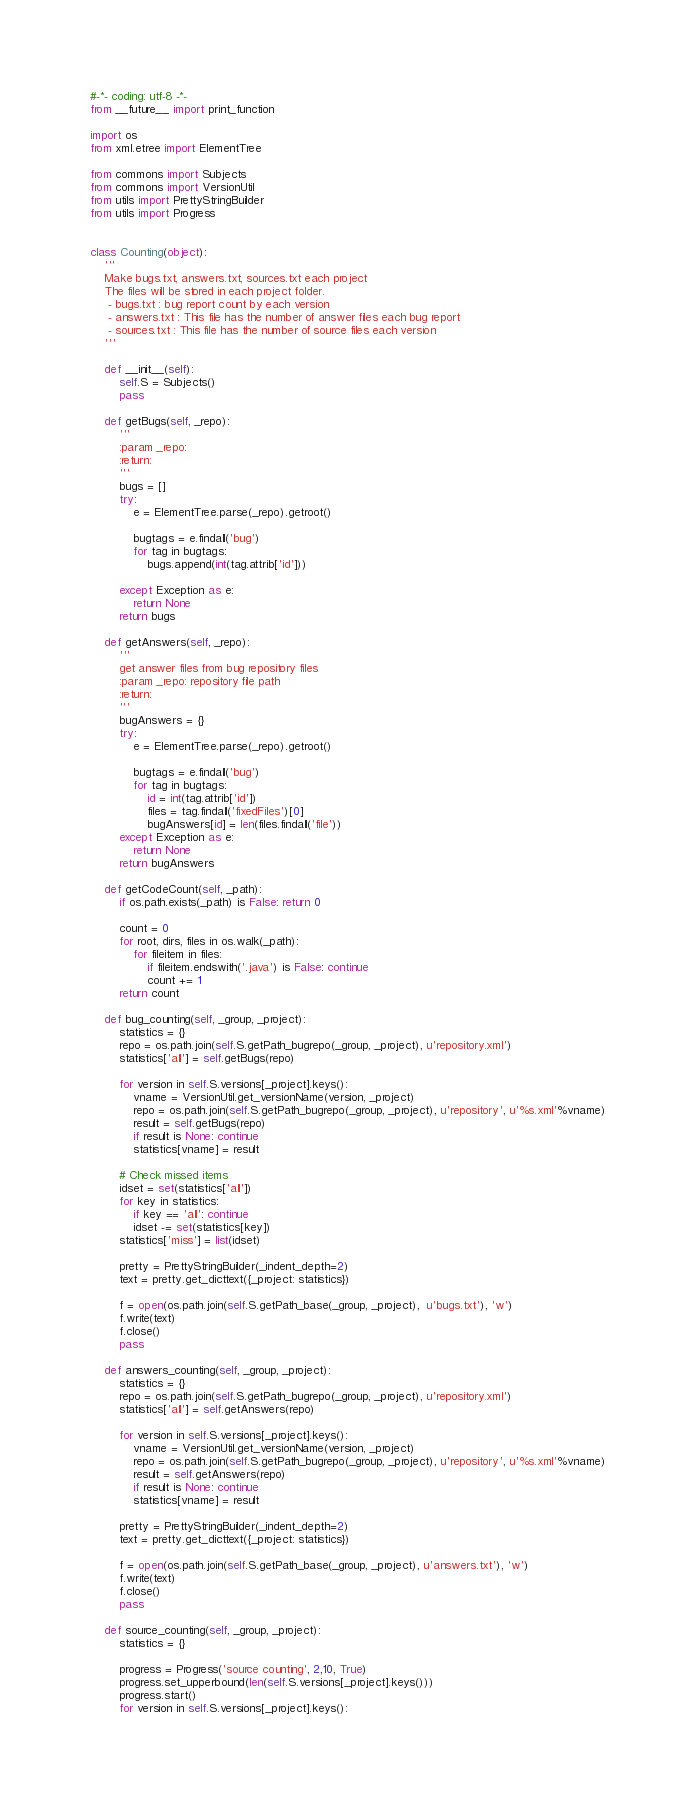Convert code to text. <code><loc_0><loc_0><loc_500><loc_500><_Python_>#-*- coding: utf-8 -*-
from __future__ import print_function

import os
from xml.etree import ElementTree

from commons import Subjects
from commons import VersionUtil
from utils import PrettyStringBuilder
from utils import Progress


class Counting(object):
	'''
	Make bugs.txt, answers.txt, sources.txt each project
	The files will be stored in each project folder.
	 - bugs.txt : bug report count by each version
	 - answers.txt : This file has the number of answer files each bug report
	 - sources.txt : This file has the number of source files each version
	'''

	def __init__(self):
		self.S = Subjects()
		pass

	def getBugs(self, _repo):
		'''
		:param _repo:
		:return:
		'''
		bugs = []
		try:
			e = ElementTree.parse(_repo).getroot()

			bugtags = e.findall('bug')
			for tag in bugtags:
				bugs.append(int(tag.attrib['id']))

		except Exception as e:
			return None
		return bugs

	def getAnswers(self, _repo):
		'''
		get answer files from bug repository files
		:param _repo: repository file path
		:return:
		'''
		bugAnswers = {}
		try:
			e = ElementTree.parse(_repo).getroot()

			bugtags = e.findall('bug')
			for tag in bugtags:
				id = int(tag.attrib['id'])
				files = tag.findall('fixedFiles')[0]
				bugAnswers[id] = len(files.findall('file'))
		except Exception as e:
			return None
		return bugAnswers

	def getCodeCount(self, _path):
		if os.path.exists(_path) is False: return 0

		count = 0
		for root, dirs, files in os.walk(_path):
			for fileitem in files:
				if fileitem.endswith('.java') is False: continue
				count += 1
		return count

	def bug_counting(self, _group, _project):
		statistics = {}
		repo = os.path.join(self.S.getPath_bugrepo(_group, _project), u'repository.xml')
		statistics['all'] = self.getBugs(repo)

		for version in self.S.versions[_project].keys():
			vname = VersionUtil.get_versionName(version, _project)
			repo = os.path.join(self.S.getPath_bugrepo(_group, _project), u'repository', u'%s.xml'%vname)
			result = self.getBugs(repo)
			if result is None: continue
			statistics[vname] = result

		# Check missed items
		idset = set(statistics['all'])
		for key in statistics:
			if key == 'all': continue
			idset -= set(statistics[key])
		statistics['miss'] = list(idset)

		pretty = PrettyStringBuilder(_indent_depth=2)
		text = pretty.get_dicttext({_project: statistics})

		f = open(os.path.join(self.S.getPath_base(_group, _project),  u'bugs.txt'), 'w')
		f.write(text)
		f.close()
		pass

	def answers_counting(self, _group, _project):
		statistics = {}
		repo = os.path.join(self.S.getPath_bugrepo(_group, _project), u'repository.xml')
		statistics['all'] = self.getAnswers(repo)

		for version in self.S.versions[_project].keys():
			vname = VersionUtil.get_versionName(version, _project)
			repo = os.path.join(self.S.getPath_bugrepo(_group, _project), u'repository', u'%s.xml'%vname)
			result = self.getAnswers(repo)
			if result is None: continue
			statistics[vname] = result

		pretty = PrettyStringBuilder(_indent_depth=2)
		text = pretty.get_dicttext({_project: statistics})

		f = open(os.path.join(self.S.getPath_base(_group, _project), u'answers.txt'), 'w')
		f.write(text)
		f.close()
		pass

	def source_counting(self, _group, _project):
		statistics = {}

		progress = Progress('source counting', 2,10, True)
		progress.set_upperbound(len(self.S.versions[_project].keys()))
		progress.start()
		for version in self.S.versions[_project].keys():</code> 